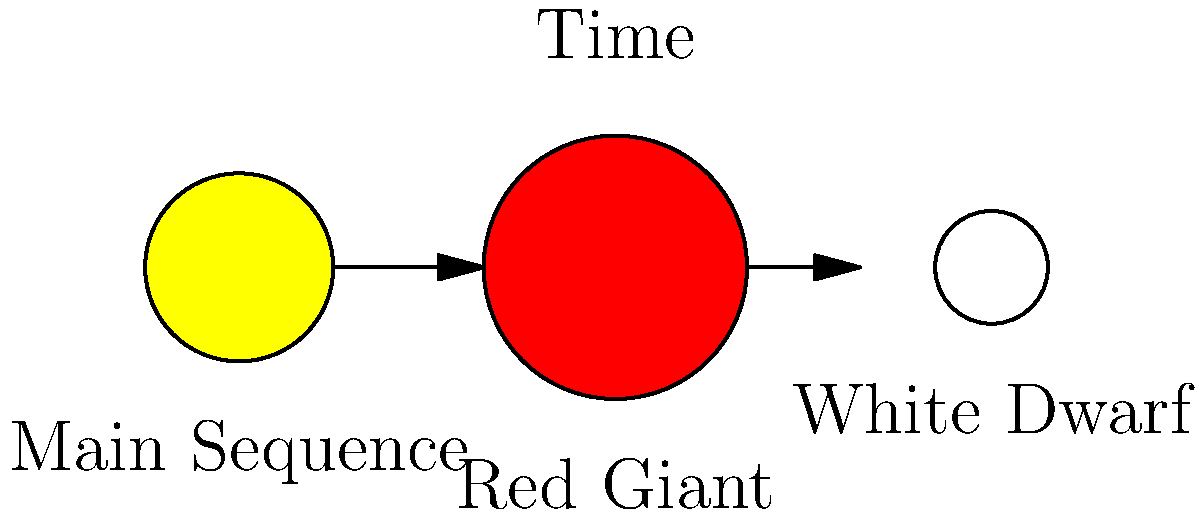In the stellar lifecycle diagram, which stage represents the most stable and longest-lasting phase of a star's life, similar to the steady state often sought in root canal treatments? To answer this question, let's analyze the stellar lifecycle stages shown in the diagram:

1. Main Sequence: This is the first stage shown in the diagram. Stars spend most of their lives in this phase, fusing hydrogen into helium in their cores. This stage is characterized by stability and consistent energy output.

2. Red Giant: As the star exhausts its core hydrogen, it expands and cools, becoming a red giant. This stage is relatively short-lived compared to the main sequence.

3. White Dwarf: This is the final stage for low to medium-mass stars. The star has shed its outer layers and is no longer undergoing fusion reactions.

The most stable and longest-lasting phase is the Main Sequence. During this stage, the star maintains a balance between gravitational collapse and outward pressure from fusion reactions. This equilibrium is similar to the steady state sought in root canal treatments, where the goal is to achieve a stable, infection-free environment in the tooth.

The duration of the Main Sequence phase depends on the star's mass but typically lasts for billions of years. For example, our Sun has been in the Main Sequence for about 4.6 billion years and is expected to remain there for another 5 billion years.

In contrast, the Red Giant and White Dwarf stages are much shorter and represent more dramatic changes in the star's structure and energy production.
Answer: Main Sequence 